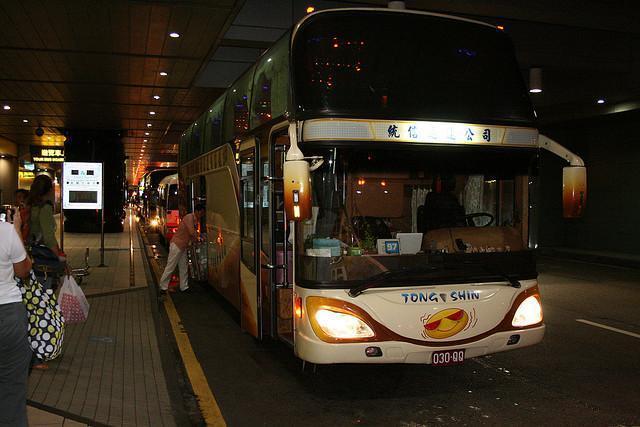How many people are driving a motorcycle in this image?
Give a very brief answer. 0. 